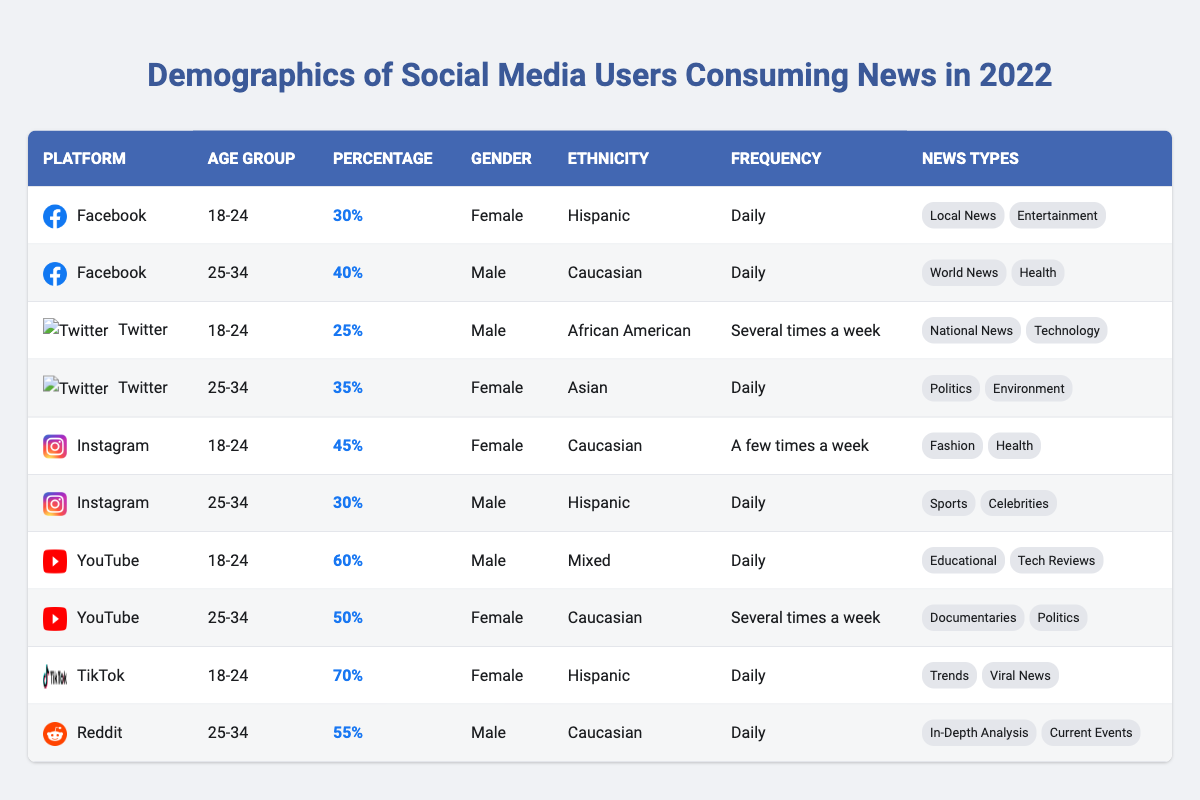What percentage of Instagram users in the age group 18-24 consume news? From the table, the percentage of Instagram users aged 18-24 consuming news is highlighted as 45%.
Answer: 45% Which social media platform has the highest percentage of users aged 18-24 consuming news? Looking at the table, TikTok has the highest percentage at 70% for users in the 18-24 age group.
Answer: TikTok How many male users aged 25-34 consume news via Facebook? The table shows that the percentage of male Facebook users aged 25-34 consuming news is 40%.
Answer: 40% Is it true that all users in the age group 18-24 consume news daily? By examining the table, we can see that not all users in the 18-24 age group consume news daily; for instance, Instagram users in this age group consume news a few times a week.
Answer: No What is the frequency of news consumption for male users aged 25-34 on Reddit? The table indicates that male users aged 25-34 on Reddit consume news daily.
Answer: Daily What is the difference in the percentage of news consumption between female users aged 18-24 on YouTube and those on Twitter? According to the table, female users aged 18-24 on YouTube have a percentage of 60%, while those on Twitter have a percentage of 25%. The difference is 60% - 25% = 35%.
Answer: 35% Which ethnicity has the highest percentage of female users consuming news on TikTok? The table shows that Hispanic female users consume news on TikTok at a rate of 70%, which is the highest percentage for female users.
Answer: Hispanic How frequent is the news consumption for female users in the age group 25-34 on YouTube compared to those on Facebook? On YouTube, the frequency is several times a week for females aged 25-34, while on Facebook, it's daily. This indicates that Facebook users consume news more frequently than YouTube users in this demographic.
Answer: Daily (Facebook), Several times a week (YouTube) What types of news do male users aged 25-34 typically consume on Instagram? The table lists that male users aged 25-34 typically consume news related to Sports and Celebrities on Instagram.
Answer: Sports, Celebrities In total, what percentage of Facebook users aged 25-34 consume World News? The table specifies that 40% of Facebook users aged 25-34 consume World News. Thus, the total is 40%.
Answer: 40% 